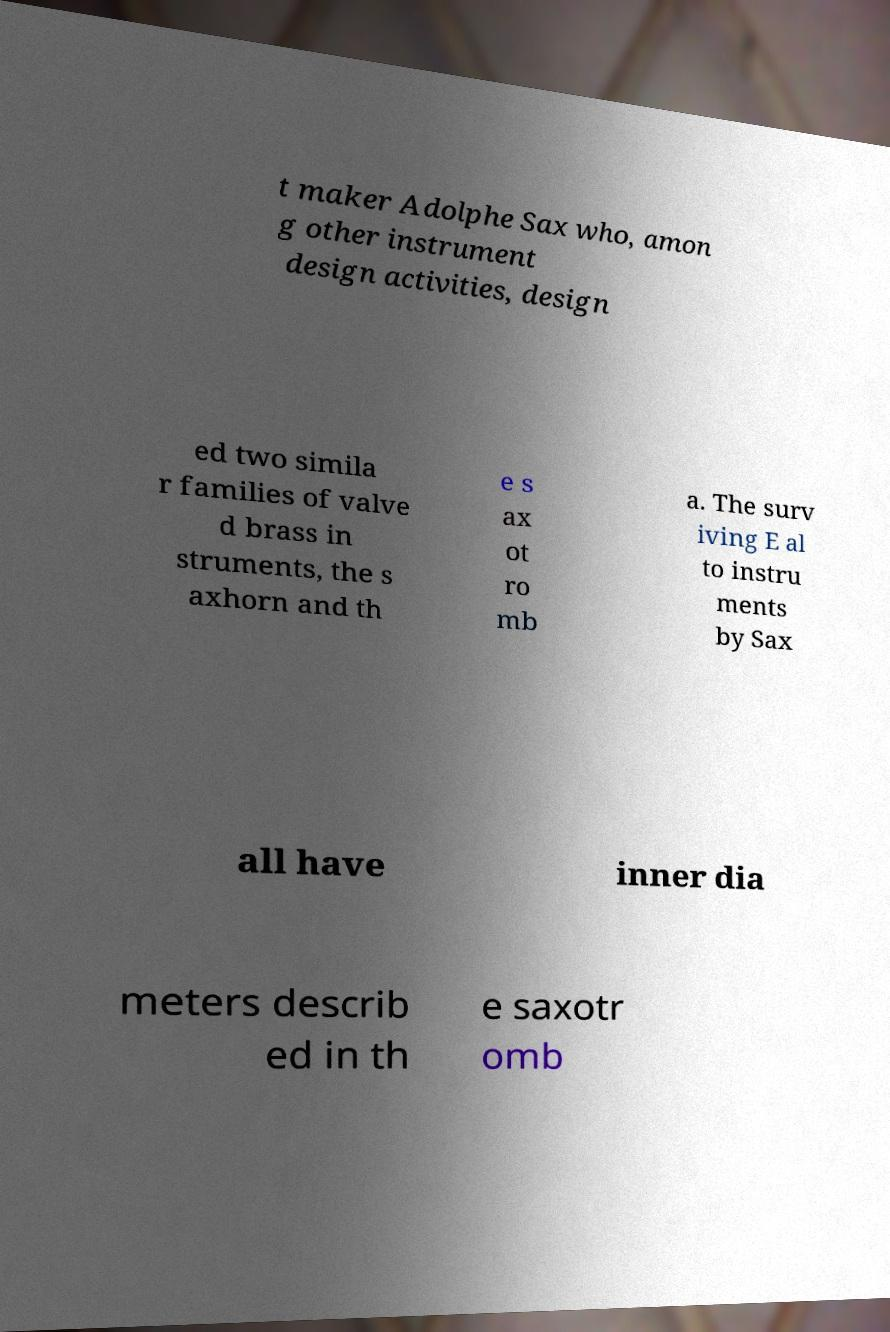Could you extract and type out the text from this image? t maker Adolphe Sax who, amon g other instrument design activities, design ed two simila r families of valve d brass in struments, the s axhorn and th e s ax ot ro mb a. The surv iving E al to instru ments by Sax all have inner dia meters describ ed in th e saxotr omb 